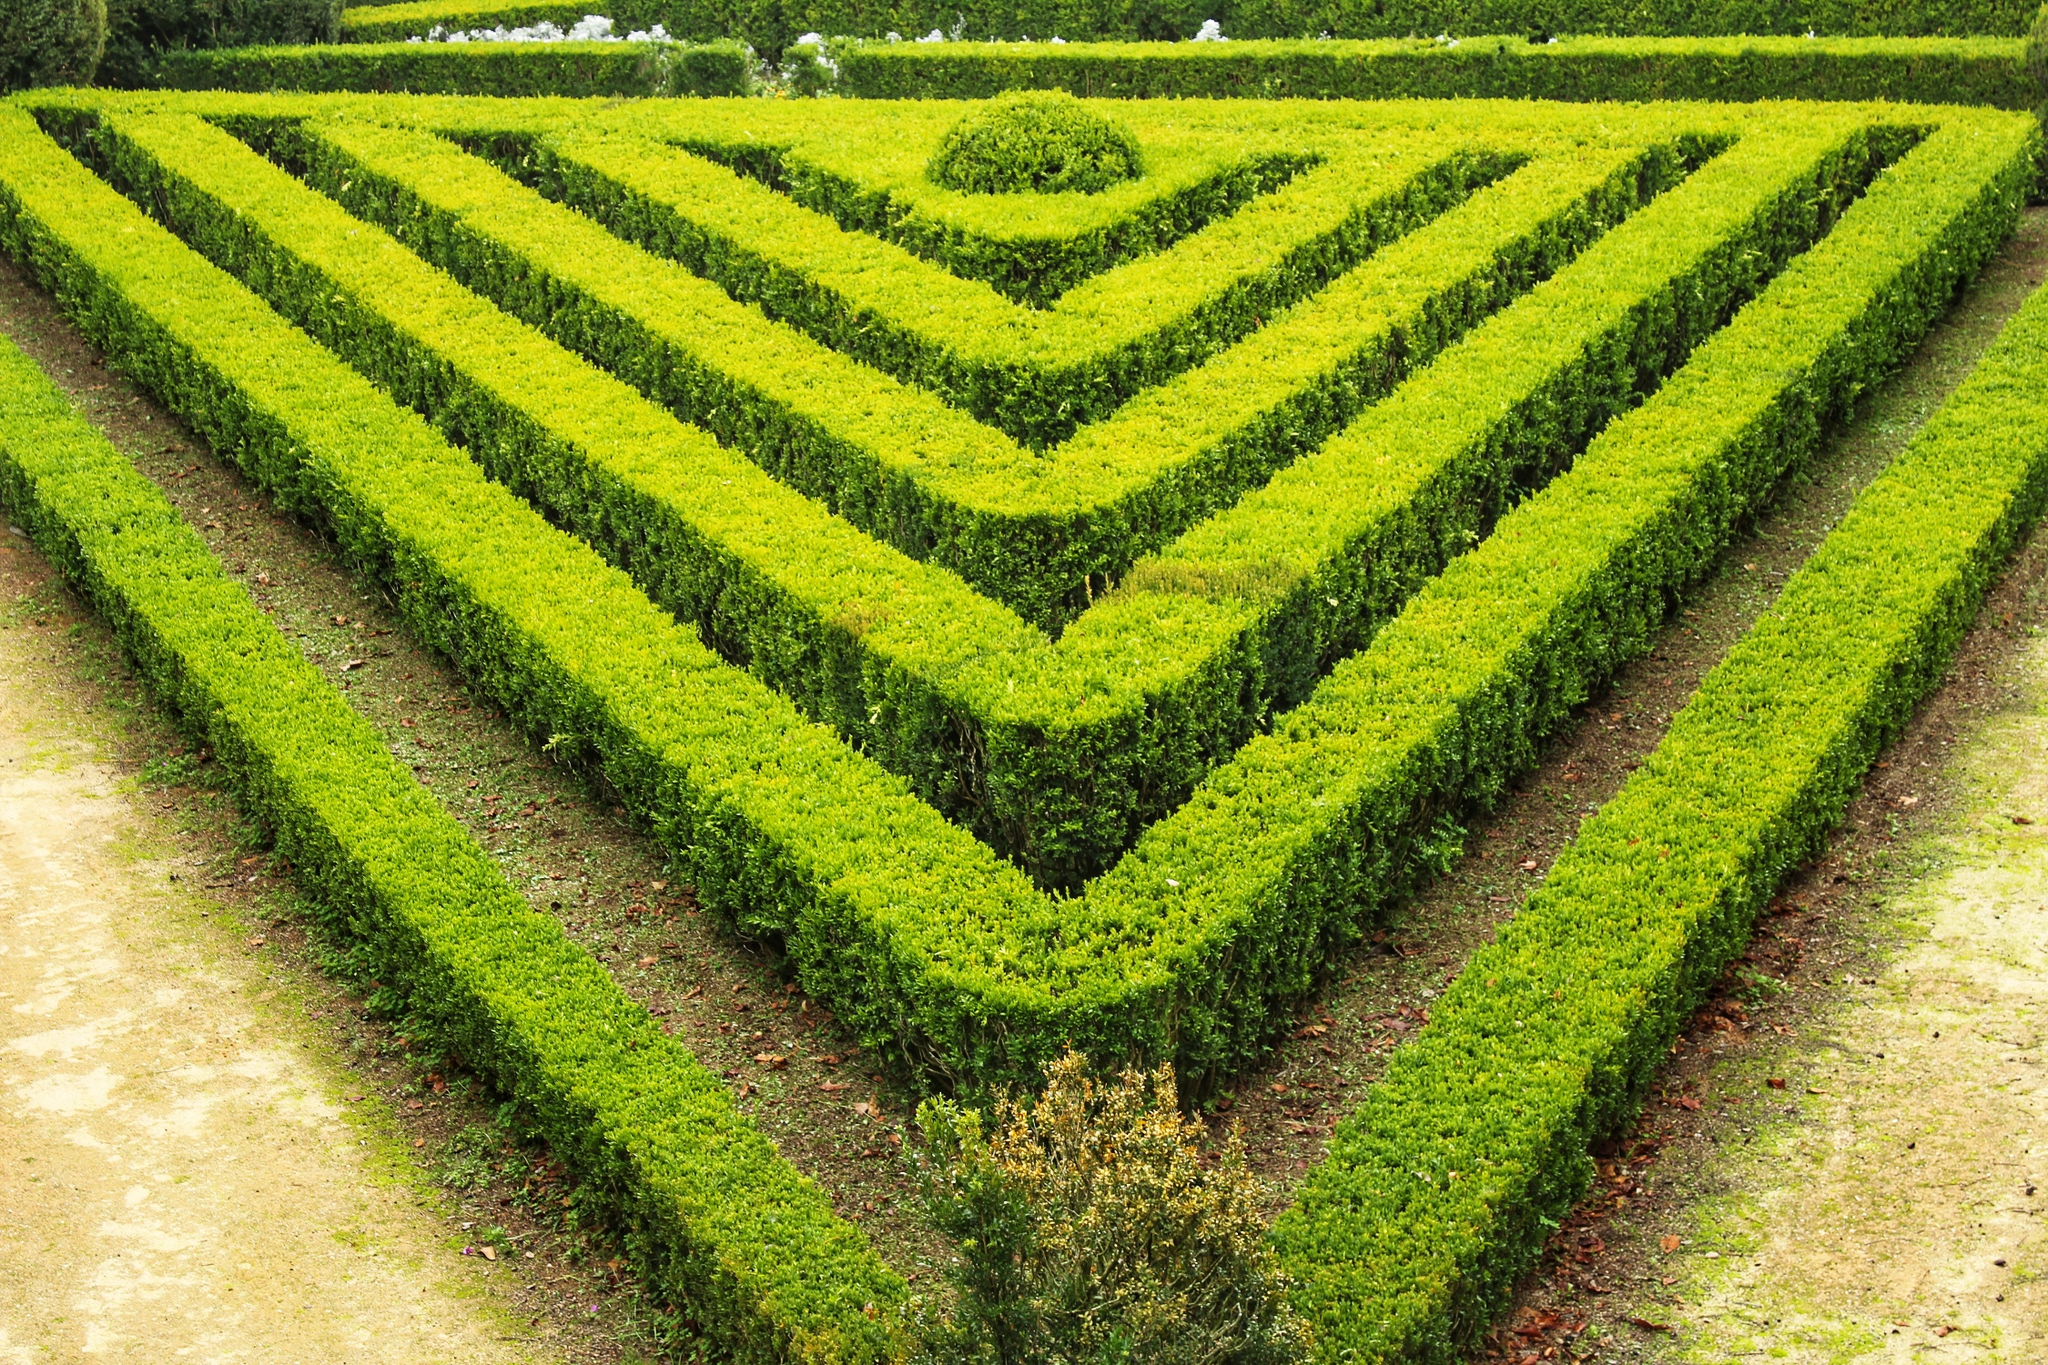What if this garden was part of a historical palace? How would you describe its significance? If this garden were part of a historical palace, it would likely serve as a testament to the grandeur and sophistication of the era in which it was designed. The geometric precision and meticulous maintenance of the garden would reflect the wealth and attention to detail of the palace's inhabitants. Such a garden would be a symbol of status and power, showcasing the ability to tame and organize nature into an artistic expression of human ingenuity. It might host grand events and gatherings, offering a serene and elegant setting for royals and dignitaries. The presence of small trees could signify life and continuity, standing as living monuments amid the historical architecture surrounding the garden. The garden's design and maintained beauty would speak volumes about the cultural and historical values placed on landscaping and aesthetics by its creators. 